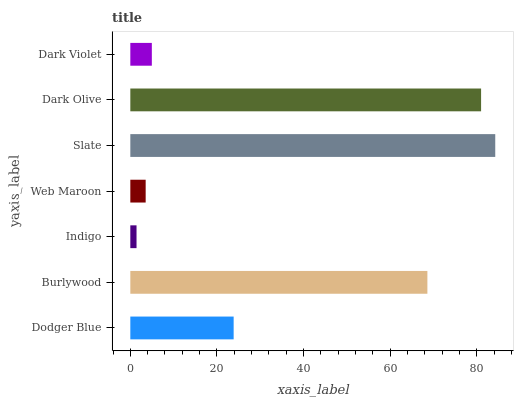Is Indigo the minimum?
Answer yes or no. Yes. Is Slate the maximum?
Answer yes or no. Yes. Is Burlywood the minimum?
Answer yes or no. No. Is Burlywood the maximum?
Answer yes or no. No. Is Burlywood greater than Dodger Blue?
Answer yes or no. Yes. Is Dodger Blue less than Burlywood?
Answer yes or no. Yes. Is Dodger Blue greater than Burlywood?
Answer yes or no. No. Is Burlywood less than Dodger Blue?
Answer yes or no. No. Is Dodger Blue the high median?
Answer yes or no. Yes. Is Dodger Blue the low median?
Answer yes or no. Yes. Is Indigo the high median?
Answer yes or no. No. Is Dark Violet the low median?
Answer yes or no. No. 